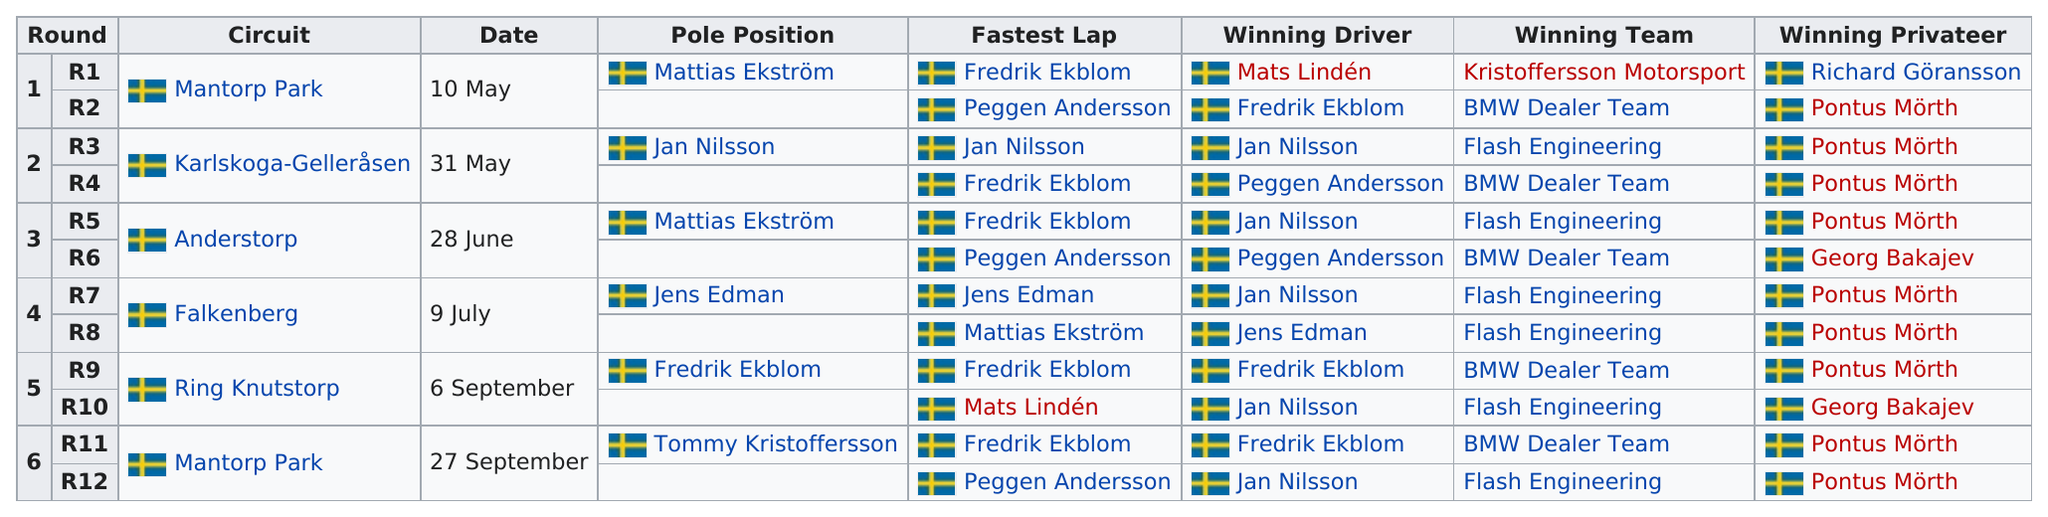Specify some key components in this picture. Six dates are listed in total. The winning team in Kristoffersson Motorsport's name is the first. The driver who was listed as the winning driver more than any other driver was Jan Nilsson. On May 31st, the date preceding June 28th was listed. Flash Engineering is the racing team that has won the most races this season. 